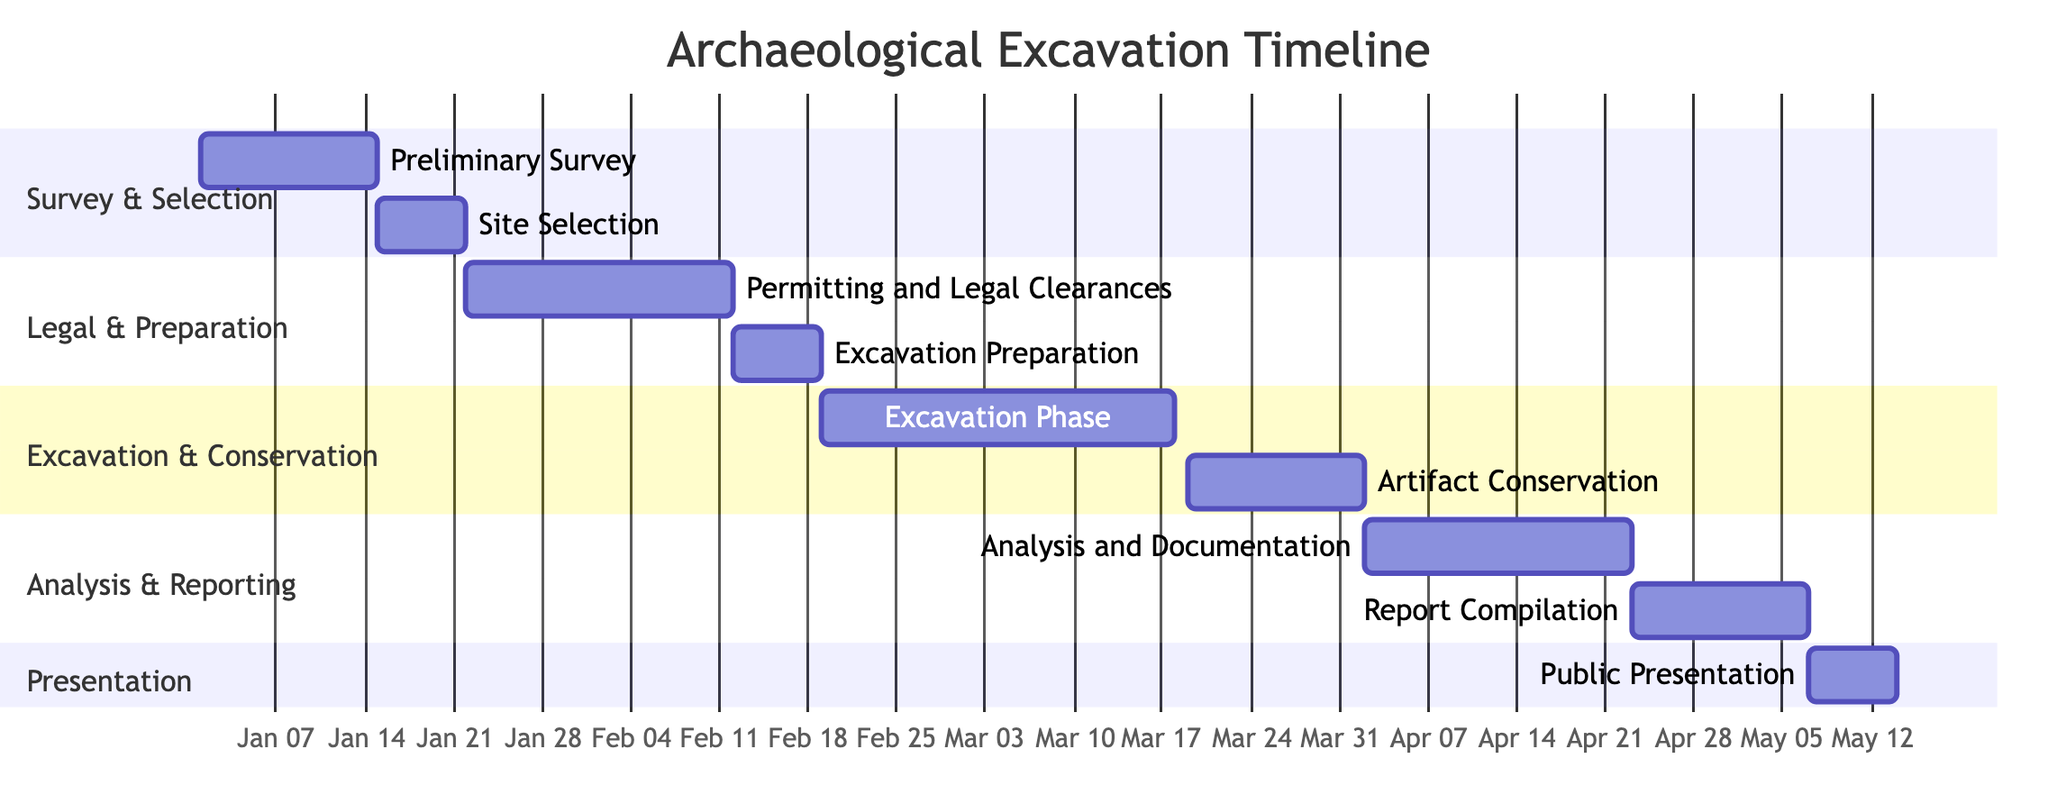What is the duration of the Excavation Phase? The Excavation Phase shows a duration of 4 weeks in the diagram, which is explicitly stated next to the phase label.
Answer: 4 weeks During which dates did the Artifact Conservation take place? The dates for Artifact Conservation are labeled in the diagram as starting on 2024-03-19 and ending on 2024-04-01.
Answer: March 19 to April 1, 2024 How many weeks are allocated for the Public Presentation? The Public Presentation phase is indicated to last for 1 week on the Gantt Chart.
Answer: 1 week Which phase comes immediately after the Site Selection phase? According to the timeline in the diagram, the phase following Site Selection is Permitting and Legal Clearances, as the dates sequentially follow.
Answer: Permitting and Legal Clearances What is the total duration of the Analysis and Documentation phase? The duration of Analysis and Documentation, shown on the chart, is 3 weeks, as noted next to the phase title.
Answer: 3 weeks Which two phases have the same start date? By examining the chart, both Artifact Conservation and Analysis and Documentation phases start on different dates but Artifact Conservation ends on the same date as Analysis and Documentation starts, thus there are no phases with same start dates.
Answer: None How many phases are there in the 'Excavation & Conservation' section? There are two phases present in the Excavation & Conservation section, which are Excavation Phase and Artifact Conservation, as indicated visually in this section of the diagram.
Answer: 2 phases What is the first phase in the timeline? The diagram indicates that the first phase in the timeline is the Preliminary Survey, as it starts at the beginning of the timeline on the chart.
Answer: Preliminary Survey Which phase has the longest duration? The phase with the longest duration is the Excavation Phase, which lasts 4 weeks, providing a significant timeframe compared to other phases.
Answer: Excavation Phase 